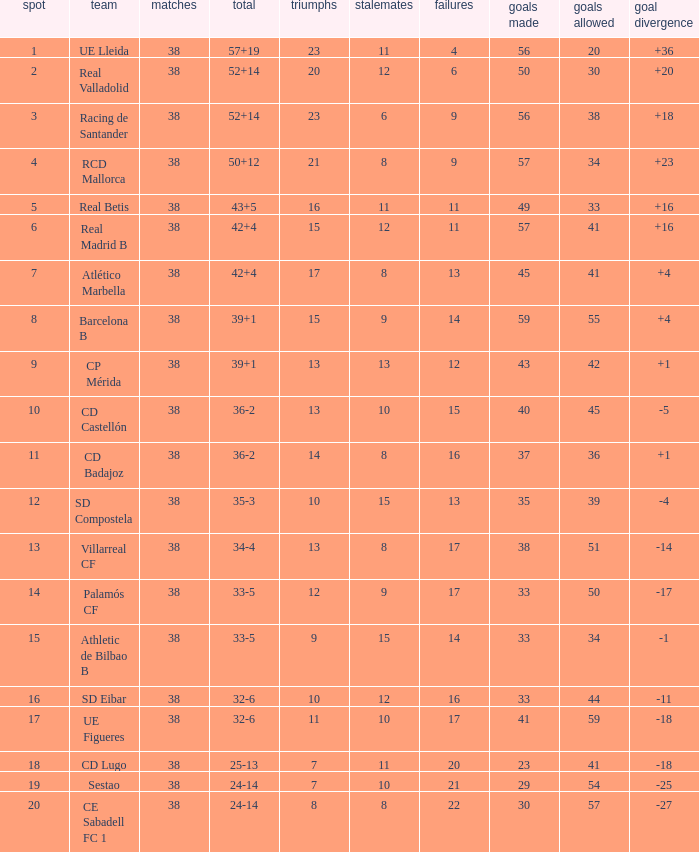What is the highest position with less than 17 losses, more than 57 goals, and a goal difference less than 4? None. Give me the full table as a dictionary. {'header': ['spot', 'team', 'matches', 'total', 'triumphs', 'stalemates', 'failures', 'goals made', 'goals allowed', 'goal divergence'], 'rows': [['1', 'UE Lleida', '38', '57+19', '23', '11', '4', '56', '20', '+36'], ['2', 'Real Valladolid', '38', '52+14', '20', '12', '6', '50', '30', '+20'], ['3', 'Racing de Santander', '38', '52+14', '23', '6', '9', '56', '38', '+18'], ['4', 'RCD Mallorca', '38', '50+12', '21', '8', '9', '57', '34', '+23'], ['5', 'Real Betis', '38', '43+5', '16', '11', '11', '49', '33', '+16'], ['6', 'Real Madrid B', '38', '42+4', '15', '12', '11', '57', '41', '+16'], ['7', 'Atlético Marbella', '38', '42+4', '17', '8', '13', '45', '41', '+4'], ['8', 'Barcelona B', '38', '39+1', '15', '9', '14', '59', '55', '+4'], ['9', 'CP Mérida', '38', '39+1', '13', '13', '12', '43', '42', '+1'], ['10', 'CD Castellón', '38', '36-2', '13', '10', '15', '40', '45', '-5'], ['11', 'CD Badajoz', '38', '36-2', '14', '8', '16', '37', '36', '+1'], ['12', 'SD Compostela', '38', '35-3', '10', '15', '13', '35', '39', '-4'], ['13', 'Villarreal CF', '38', '34-4', '13', '8', '17', '38', '51', '-14'], ['14', 'Palamós CF', '38', '33-5', '12', '9', '17', '33', '50', '-17'], ['15', 'Athletic de Bilbao B', '38', '33-5', '9', '15', '14', '33', '34', '-1'], ['16', 'SD Eibar', '38', '32-6', '10', '12', '16', '33', '44', '-11'], ['17', 'UE Figueres', '38', '32-6', '11', '10', '17', '41', '59', '-18'], ['18', 'CD Lugo', '38', '25-13', '7', '11', '20', '23', '41', '-18'], ['19', 'Sestao', '38', '24-14', '7', '10', '21', '29', '54', '-25'], ['20', 'CE Sabadell FC 1', '38', '24-14', '8', '8', '22', '30', '57', '-27']]} 